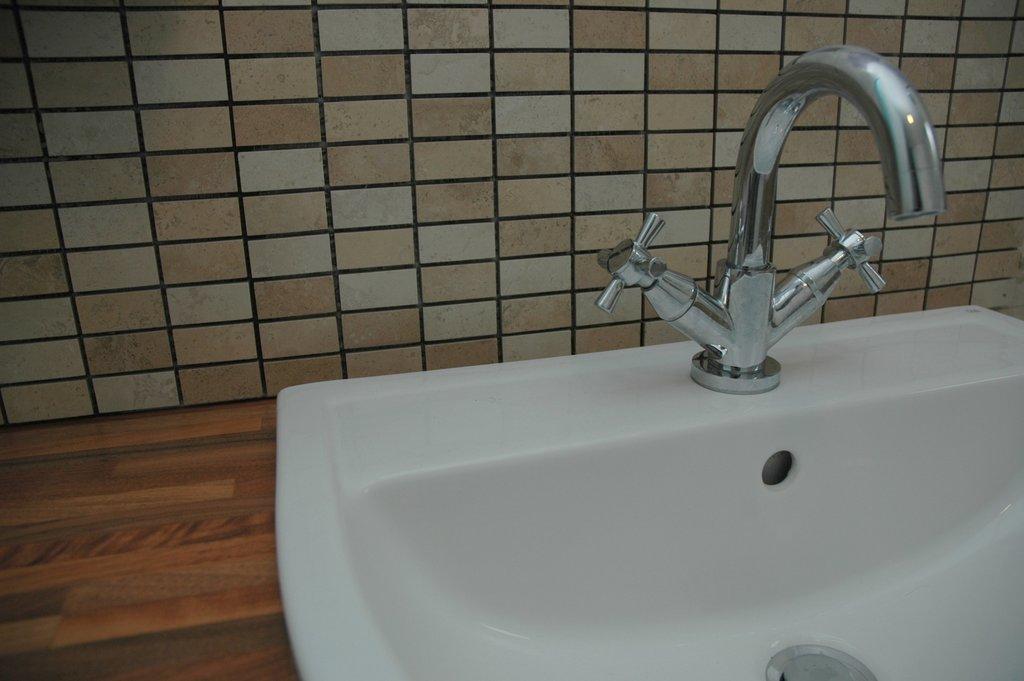Could you give a brief overview of what you see in this image? In this image we can see one white sink with a tap on the surface, near to the wall. 